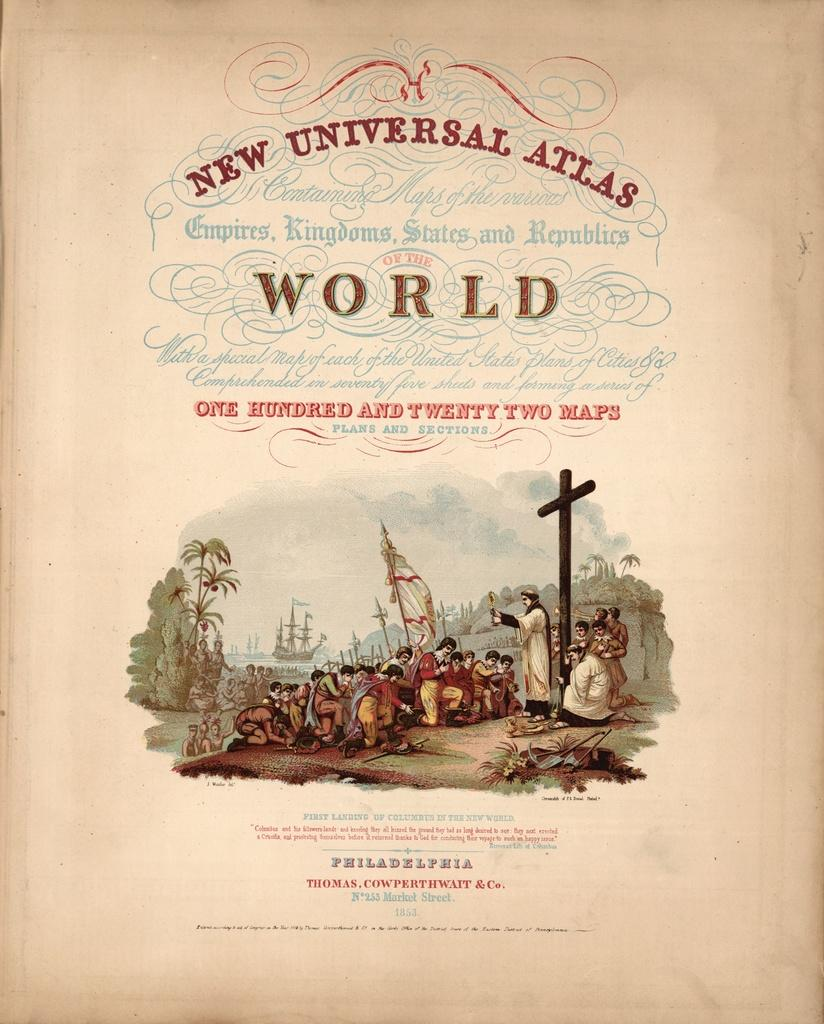<image>
Provide a brief description of the given image. The cover of a book that is titled New Universal Atlas. 